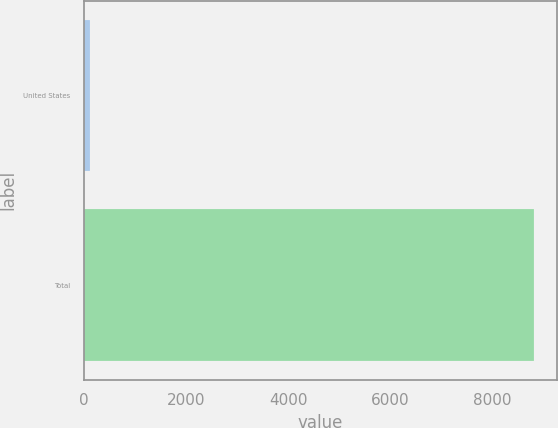Convert chart to OTSL. <chart><loc_0><loc_0><loc_500><loc_500><bar_chart><fcel>United States<fcel>Total<nl><fcel>119<fcel>8811<nl></chart> 